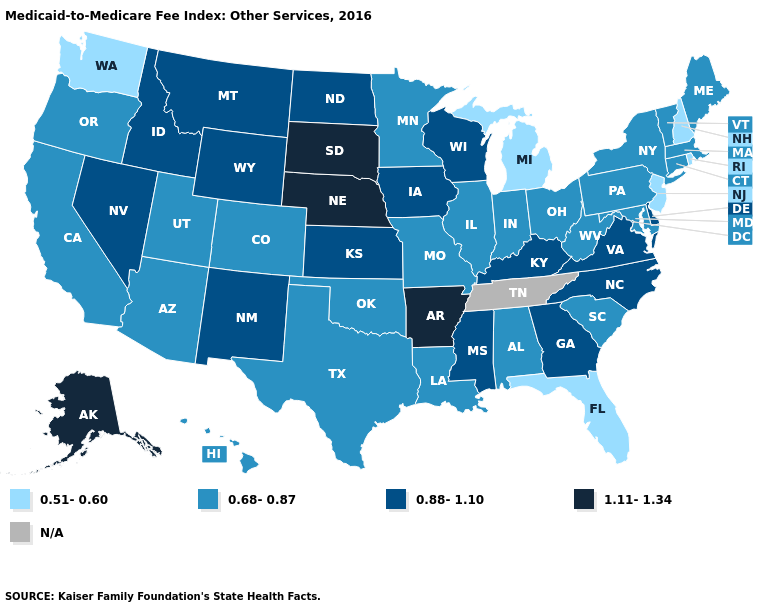Which states have the lowest value in the USA?
Be succinct. Florida, Michigan, New Hampshire, New Jersey, Rhode Island, Washington. Name the states that have a value in the range 0.51-0.60?
Concise answer only. Florida, Michigan, New Hampshire, New Jersey, Rhode Island, Washington. What is the value of Wisconsin?
Short answer required. 0.88-1.10. What is the value of Louisiana?
Give a very brief answer. 0.68-0.87. Among the states that border North Carolina , which have the highest value?
Quick response, please. Georgia, Virginia. What is the value of Louisiana?
Quick response, please. 0.68-0.87. What is the lowest value in states that border Vermont?
Answer briefly. 0.51-0.60. How many symbols are there in the legend?
Write a very short answer. 5. Name the states that have a value in the range 0.88-1.10?
Quick response, please. Delaware, Georgia, Idaho, Iowa, Kansas, Kentucky, Mississippi, Montana, Nevada, New Mexico, North Carolina, North Dakota, Virginia, Wisconsin, Wyoming. Name the states that have a value in the range 0.68-0.87?
Answer briefly. Alabama, Arizona, California, Colorado, Connecticut, Hawaii, Illinois, Indiana, Louisiana, Maine, Maryland, Massachusetts, Minnesota, Missouri, New York, Ohio, Oklahoma, Oregon, Pennsylvania, South Carolina, Texas, Utah, Vermont, West Virginia. What is the value of California?
Write a very short answer. 0.68-0.87. What is the highest value in the USA?
Answer briefly. 1.11-1.34. Which states have the lowest value in the USA?
Concise answer only. Florida, Michigan, New Hampshire, New Jersey, Rhode Island, Washington. 